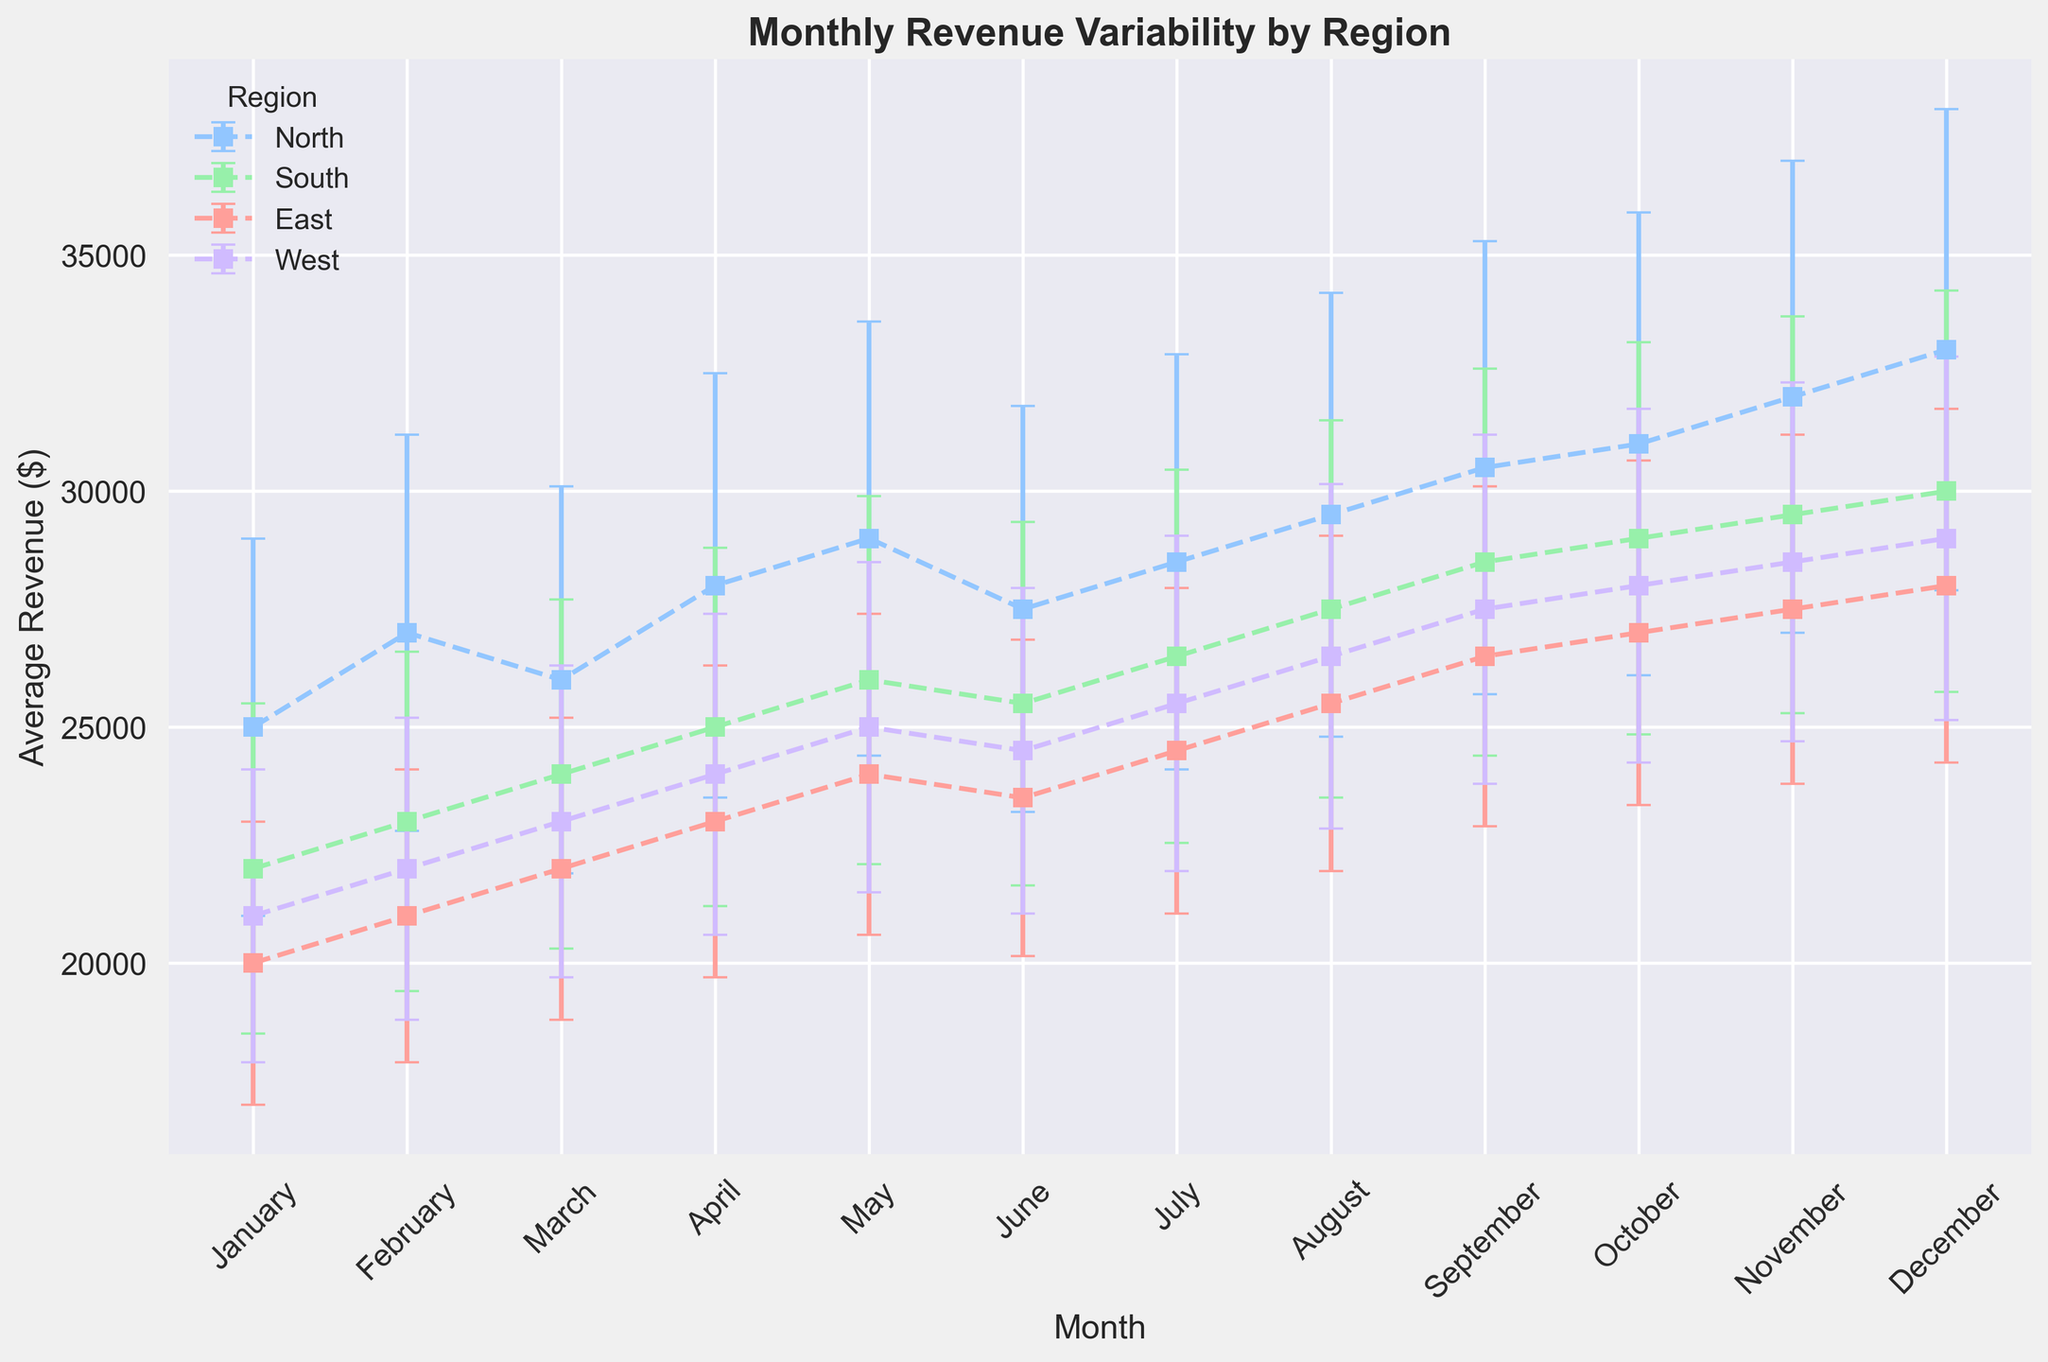Which region has the highest average revenue in December? Look at the average revenue values for each region in December. The values are: North - 33000, South - 30000, East - 28000, and West - 29000. The highest value is for North.
Answer: North In which month does the South region show the highest revenue variability? Check the revenue standard deviation (SD) for the South region across all months. The month with the highest SD is December with 4250.
Answer: December What is the combined average revenue of the East region in January and February? Sum the average revenues of the East region for January (20000) and February (21000). The combined revenue is 20000 + 21000.
Answer: 41000 Which region shows the smallest revenue variability in March? Compare the revenue standard deviation (SD) for all regions in March. The values are: North - 4100, South - 3700, East - 3200, and West - 3300. The smallest value is for the East.
Answer: East What is the overall trend of average revenue from January to December for the West region? Analyze the average revenue values for the West region from January (21000) to December (29000). The values show an upward trend.
Answer: Upward trend Which region had a higher average revenue in May, the North or the South? Compare the average revenue for the North (29000) and the South (26000) in May. The North had a higher value.
Answer: North How does the revenue variability in January compare between the East and West regions? Compare the revenue standard deviation (SD) in January for East (3000) and West (3100). The East has a slightly lower variability.
Answer: The East has slightly lower variability What is the average revenue for the North region in Q1 (January to March)? Calculate the average revenue for January (25000), February (27000), and March (26000) in the North region. The sum is 25000 + 27000 + 26000 = 78000. Divide 78000 by 3 to find the average.
Answer: 26000 Which region shows the least revenue variability in October? Compare the revenue standard deviation (SD) for all regions in October. The values are: North - 4900, South - 4150, East - 3650, and West - 3750. The East has the smallest value.
Answer: East Does the South region's average revenue in November surpass that of the East in the same month? Compare the average revenue for South (29500) and East (27500) in November. The South's revenue is higher.
Answer: Yes 